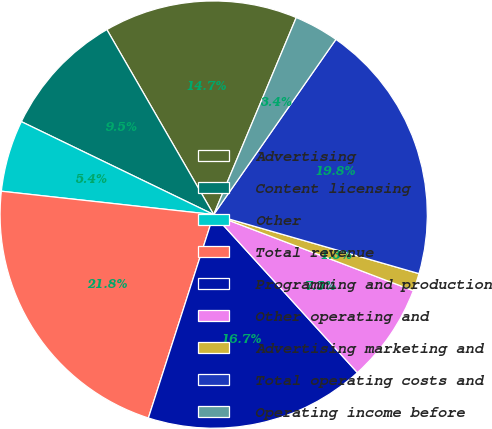Convert chart. <chart><loc_0><loc_0><loc_500><loc_500><pie_chart><fcel>Advertising<fcel>Content licensing<fcel>Other<fcel>Total revenue<fcel>Programming and production<fcel>Other operating and<fcel>Advertising marketing and<fcel>Total operating costs and<fcel>Operating income before<nl><fcel>14.65%<fcel>9.5%<fcel>5.42%<fcel>21.8%<fcel>16.69%<fcel>7.46%<fcel>1.34%<fcel>19.76%<fcel>3.38%<nl></chart> 